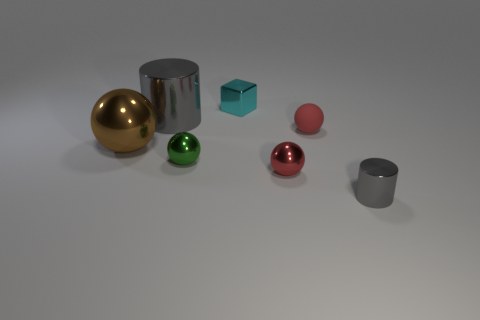Can you describe the size and color of the spherical objects in the image? Certainly, there are two spherical objects: one is fairly large with a shiny gold finish, and the other is smaller and has a glossy red surface. They add a vibrant touch to the image with their reflective textures. 